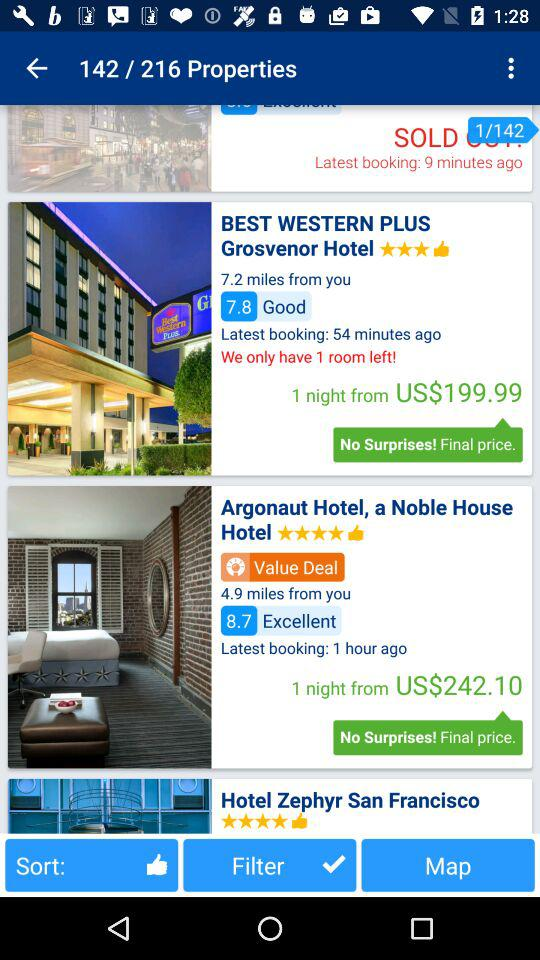How many rooms are left in the Western Plus Grosvenor Hotel? There is 1 room left at the Western Plus Grosvenor Hotel. 